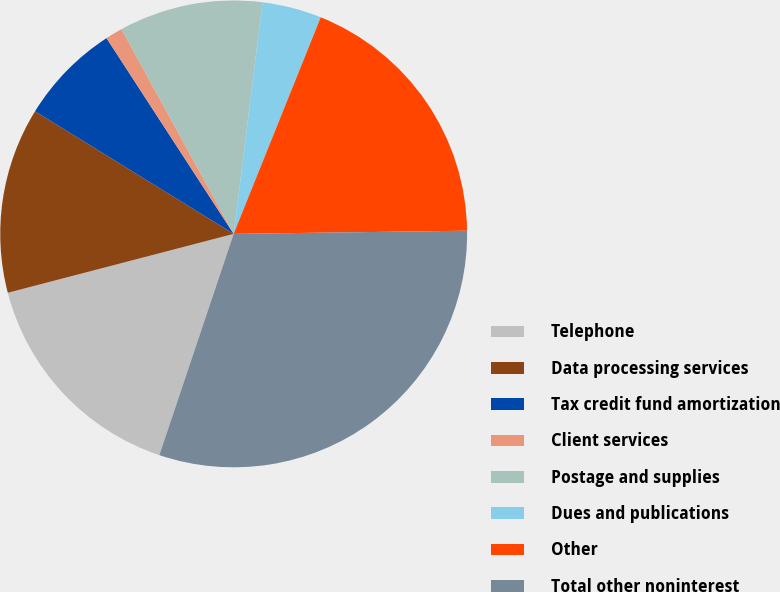Convert chart. <chart><loc_0><loc_0><loc_500><loc_500><pie_chart><fcel>Telephone<fcel>Data processing services<fcel>Tax credit fund amortization<fcel>Client services<fcel>Postage and supplies<fcel>Dues and publications<fcel>Other<fcel>Total other noninterest<nl><fcel>15.78%<fcel>12.86%<fcel>7.03%<fcel>1.19%<fcel>9.95%<fcel>4.11%<fcel>18.7%<fcel>30.37%<nl></chart> 